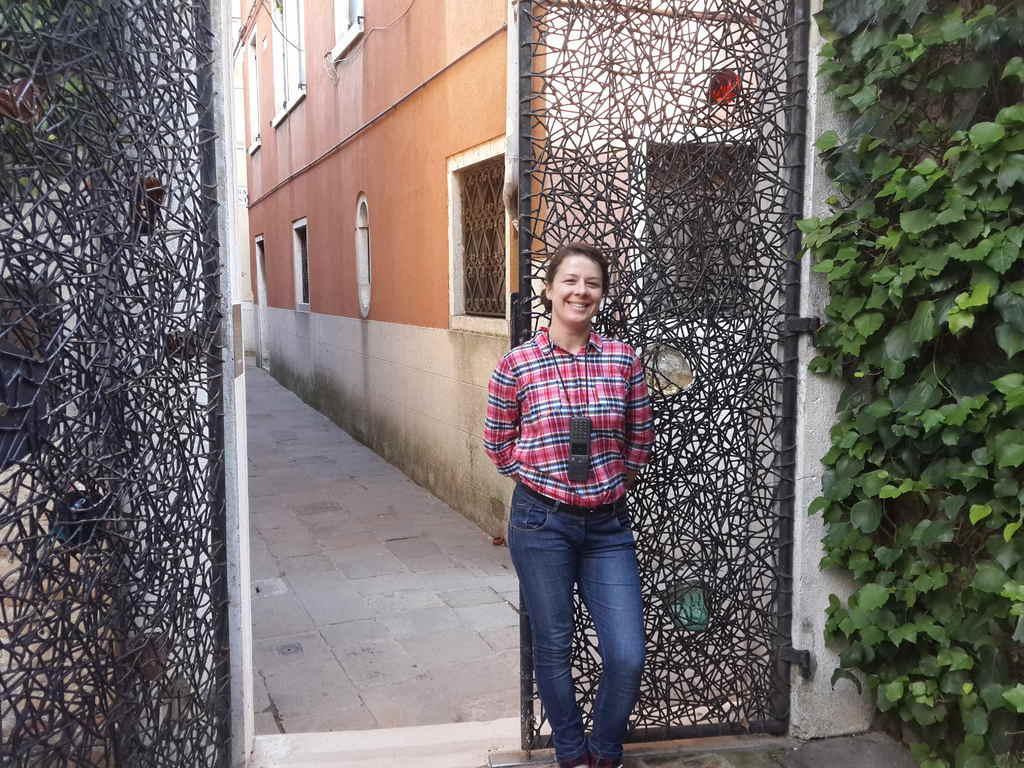Could you give a brief overview of what you see in this image? In the middle a beautiful girl is standing, she wore shirt, trouser. Behind her it's an iron gate and on the right side there are plants, this is a building. 